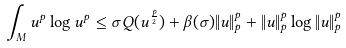Convert formula to latex. <formula><loc_0><loc_0><loc_500><loc_500>\int _ { M } u ^ { p } \log u ^ { p } \leq \sigma Q ( u ^ { \frac { p } { 2 } } ) + \beta ( \sigma ) \| u \| _ { p } ^ { p } + \| u \| _ { p } ^ { p } \log \| u \| _ { p } ^ { p }</formula> 